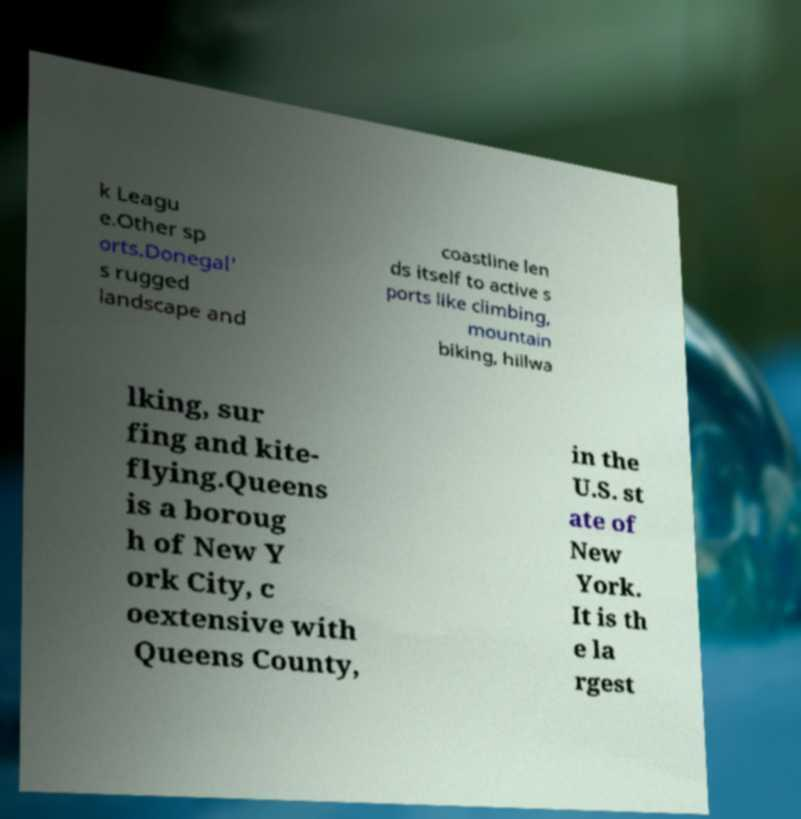I need the written content from this picture converted into text. Can you do that? k Leagu e.Other sp orts.Donegal' s rugged landscape and coastline len ds itself to active s ports like climbing, mountain biking, hillwa lking, sur fing and kite- flying.Queens is a boroug h of New Y ork City, c oextensive with Queens County, in the U.S. st ate of New York. It is th e la rgest 